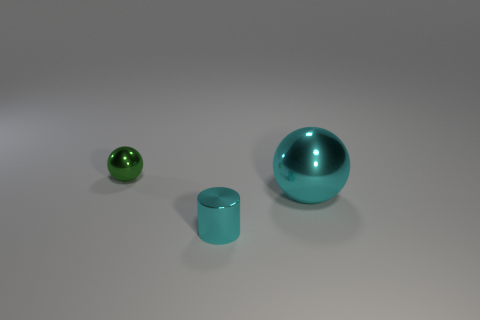Add 2 big cylinders. How many objects exist? 5 Subtract all cylinders. How many objects are left? 2 Subtract all balls. Subtract all small cyan metallic objects. How many objects are left? 0 Add 1 green metallic things. How many green metallic things are left? 2 Add 1 small metallic cylinders. How many small metallic cylinders exist? 2 Subtract 0 yellow cylinders. How many objects are left? 3 